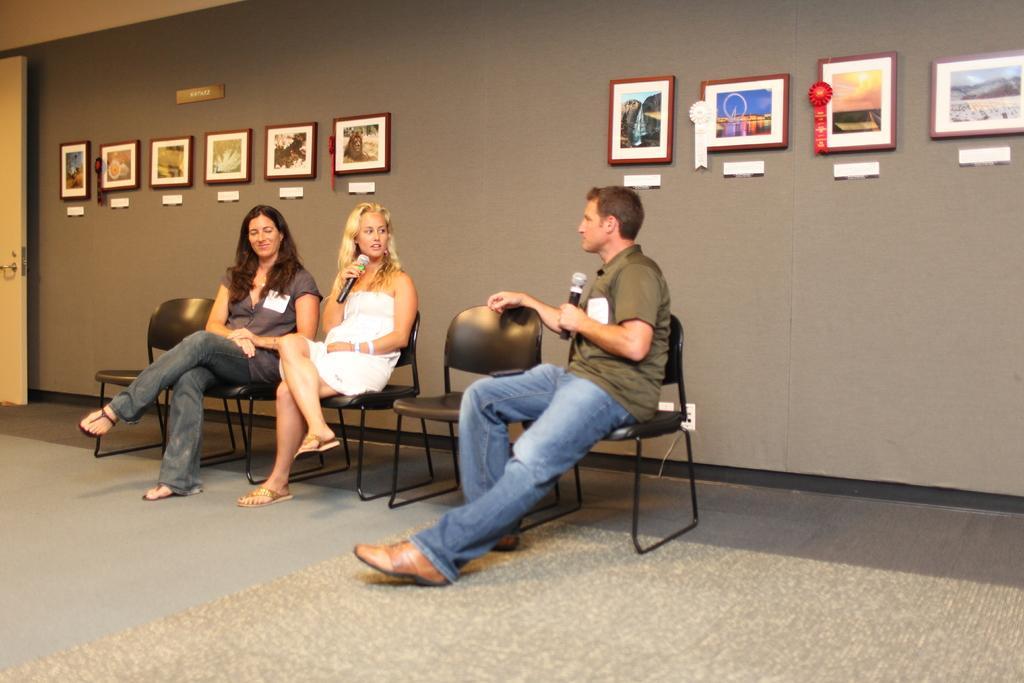In one or two sentences, can you explain what this image depicts? In this picture does the men and two women sitting one of them is smiling and another one is speaking to the man. This women is holding a microphone with her right hand and this man is holding his microphone with his left hand and there are some empty chairs the less, there is a door in the left and in the background there is a wall with some photo frames placed on it and the floor has a carpet. 